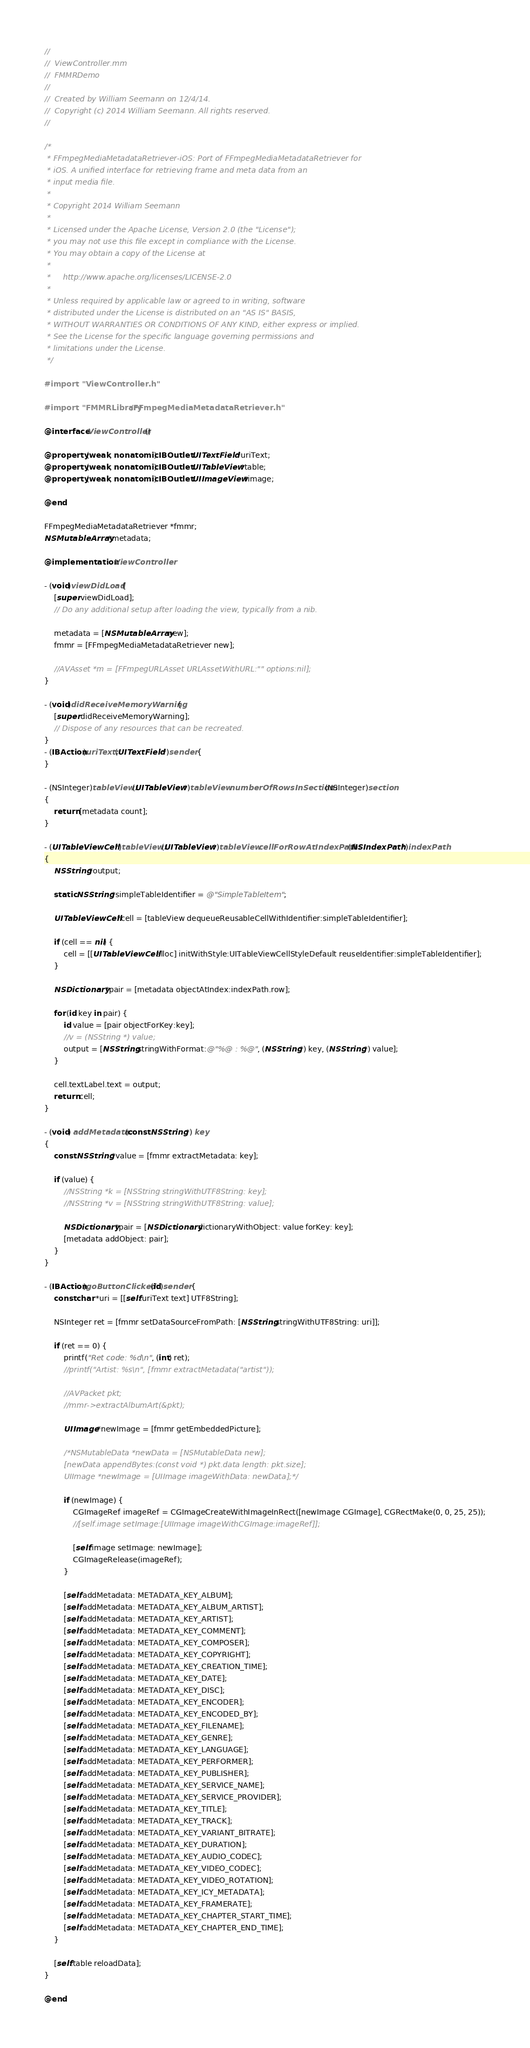Convert code to text. <code><loc_0><loc_0><loc_500><loc_500><_ObjectiveC_>//
//  ViewController.mm
//  FMMRDemo
//
//  Created by William Seemann on 12/4/14.
//  Copyright (c) 2014 William Seemann. All rights reserved.
//

/*
 * FFmpegMediaMetadataRetriever-iOS: Port of FFmpegMediaMetadataRetriever for
 * iOS. A unified interface for retrieving frame and meta data from an
 * input media file.
 *
 * Copyright 2014 William Seemann
 *
 * Licensed under the Apache License, Version 2.0 (the "License");
 * you may not use this file except in compliance with the License.
 * You may obtain a copy of the License at
 *
 *     http://www.apache.org/licenses/LICENSE-2.0
 *
 * Unless required by applicable law or agreed to in writing, software
 * distributed under the License is distributed on an "AS IS" BASIS,
 * WITHOUT WARRANTIES OR CONDITIONS OF ANY KIND, either express or implied.
 * See the License for the specific language governing permissions and
 * limitations under the License.
 */

#import "ViewController.h"

#import "FMMRLibrary/FFmpegMediaMetadataRetriever.h"

@interface ViewController ()

@property (weak, nonatomic) IBOutlet UITextField *uriText;
@property (weak, nonatomic) IBOutlet UITableView *table;
@property (weak, nonatomic) IBOutlet UIImageView *image;

@end

FFmpegMediaMetadataRetriever *fmmr;
NSMutableArray *metadata;

@implementation ViewController

- (void)viewDidLoad {
    [super viewDidLoad];
    // Do any additional setup after loading the view, typically from a nib.
    
    metadata = [NSMutableArray new];
    fmmr = [FFmpegMediaMetadataRetriever new];
    
    //AVAsset *m = [FFmpegURLAsset URLAssetWithURL:"" options:nil];
}

- (void)didReceiveMemoryWarning {
    [super didReceiveMemoryWarning];
    // Dispose of any resources that can be recreated.
}
- (IBAction)uriText:(UITextField *)sender {
}

- (NSInteger)tableView:(UITableView *)tableView numberOfRowsInSection:(NSInteger)section
{
    return [metadata count];
}

- (UITableViewCell *)tableView:(UITableView *)tableView cellForRowAtIndexPath:(NSIndexPath *)indexPath
{
    NSString *output;
    
    static NSString *simpleTableIdentifier = @"SimpleTableItem";
    
    UITableViewCell *cell = [tableView dequeueReusableCellWithIdentifier:simpleTableIdentifier];
    
    if (cell == nil) {
        cell = [[UITableViewCell alloc] initWithStyle:UITableViewCellStyleDefault reuseIdentifier:simpleTableIdentifier];
    }
    
    NSDictionary *pair = [metadata objectAtIndex:indexPath.row];
    
    for (id key in pair) {
        id value = [pair objectForKey:key];
        //v = (NSString *) value;
        output = [NSString stringWithFormat:@"%@ : %@", (NSString *) key, (NSString *) value];
    }
    
    cell.textLabel.text = output;
    return cell;
}

- (void) addMetadata:(const NSString *) key
{
    const NSString *value = [fmmr extractMetadata: key];
    
    if (value) {
        //NSString *k = [NSString stringWithUTF8String: key];
        //NSString *v = [NSString stringWithUTF8String: value];
        
        NSDictionary *pair = [NSDictionary dictionaryWithObject: value forKey: key];
        [metadata addObject: pair];
    }
}

- (IBAction)goButtonClicked:(id)sender {
    const char *uri = [[self.uriText text] UTF8String];
    
    NSInteger ret = [fmmr setDataSourceFromPath: [NSString stringWithUTF8String: uri]];
    
    if (ret == 0) {
        printf("Ret code: %d\n", (int) ret);
        //printf("Artist: %s\n", [fmmr extractMetadata("artist"));
        
        //AVPacket pkt;
        //mmr->extractAlbumArt(&pkt);
        
        UIImage *newImage = [fmmr getEmbeddedPicture];
        
        /*NSMutableData *newData = [NSMutableData new];
        [newData appendBytes:(const void *) pkt.data length: pkt.size];
        UIImage *newImage = [UIImage imageWithData: newData];*/
        
        if (newImage) {
            CGImageRef imageRef = CGImageCreateWithImageInRect([newImage CGImage], CGRectMake(0, 0, 25, 25));
            //[self.image setImage:[UIImage imageWithCGImage:imageRef]];
            
            [self.image setImage: newImage];
            CGImageRelease(imageRef);
        }
        
        [self addMetadata: METADATA_KEY_ALBUM];
        [self addMetadata: METADATA_KEY_ALBUM_ARTIST];
        [self addMetadata: METADATA_KEY_ARTIST];
        [self addMetadata: METADATA_KEY_COMMENT];
        [self addMetadata: METADATA_KEY_COMPOSER];
        [self addMetadata: METADATA_KEY_COPYRIGHT];
        [self addMetadata: METADATA_KEY_CREATION_TIME];
        [self addMetadata: METADATA_KEY_DATE];
        [self addMetadata: METADATA_KEY_DISC];
        [self addMetadata: METADATA_KEY_ENCODER];
        [self addMetadata: METADATA_KEY_ENCODED_BY];
        [self addMetadata: METADATA_KEY_FILENAME];
        [self addMetadata: METADATA_KEY_GENRE];
        [self addMetadata: METADATA_KEY_LANGUAGE];
        [self addMetadata: METADATA_KEY_PERFORMER];
        [self addMetadata: METADATA_KEY_PUBLISHER];
        [self addMetadata: METADATA_KEY_SERVICE_NAME];
        [self addMetadata: METADATA_KEY_SERVICE_PROVIDER];
        [self addMetadata: METADATA_KEY_TITLE];
        [self addMetadata: METADATA_KEY_TRACK];
        [self addMetadata: METADATA_KEY_VARIANT_BITRATE];
        [self addMetadata: METADATA_KEY_DURATION];
        [self addMetadata: METADATA_KEY_AUDIO_CODEC];
        [self addMetadata: METADATA_KEY_VIDEO_CODEC];
        [self addMetadata: METADATA_KEY_VIDEO_ROTATION];
        [self addMetadata: METADATA_KEY_ICY_METADATA];
        [self addMetadata: METADATA_KEY_FRAMERATE];
        [self addMetadata: METADATA_KEY_CHAPTER_START_TIME];
        [self addMetadata: METADATA_KEY_CHAPTER_END_TIME];
    }
    
    [self.table reloadData];
}

@end
</code> 